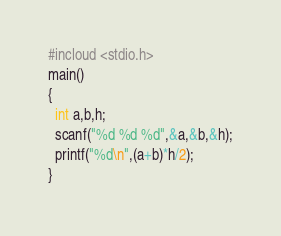Convert code to text. <code><loc_0><loc_0><loc_500><loc_500><_C_>#incloud <stdio.h>
main()
{
  int a,b,h;
  scanf("%d %d %d",&a,&b,&h);
  printf("%d\n",(a+b)*h/2);
}</code> 